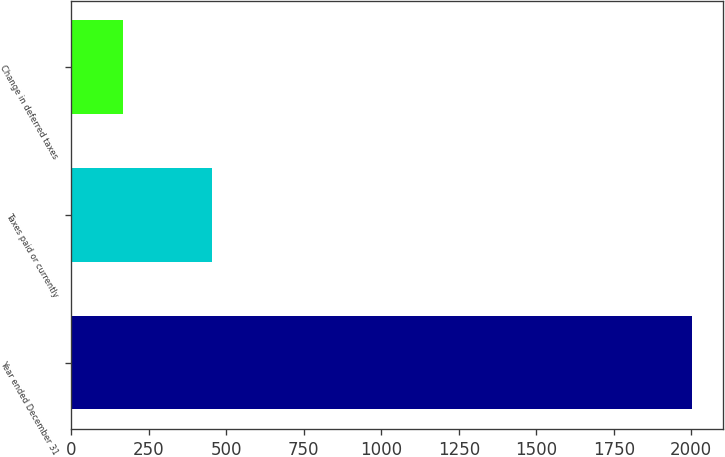Convert chart to OTSL. <chart><loc_0><loc_0><loc_500><loc_500><bar_chart><fcel>Year ended December 31<fcel>Taxes paid or currently<fcel>Change in deferred taxes<nl><fcel>2001<fcel>454<fcel>166<nl></chart> 